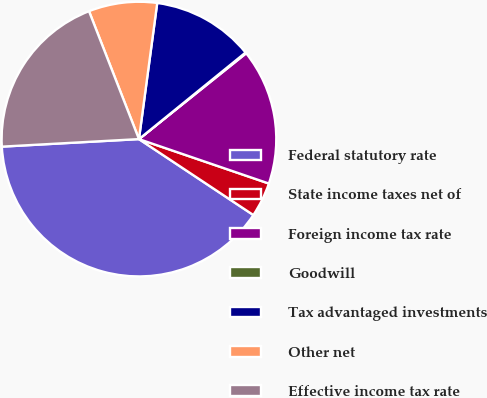Convert chart to OTSL. <chart><loc_0><loc_0><loc_500><loc_500><pie_chart><fcel>Federal statutory rate<fcel>State income taxes net of<fcel>Foreign income tax rate<fcel>Goodwill<fcel>Tax advantaged investments<fcel>Other net<fcel>Effective income tax rate<nl><fcel>39.8%<fcel>4.08%<fcel>15.99%<fcel>0.11%<fcel>12.02%<fcel>8.05%<fcel>19.95%<nl></chart> 